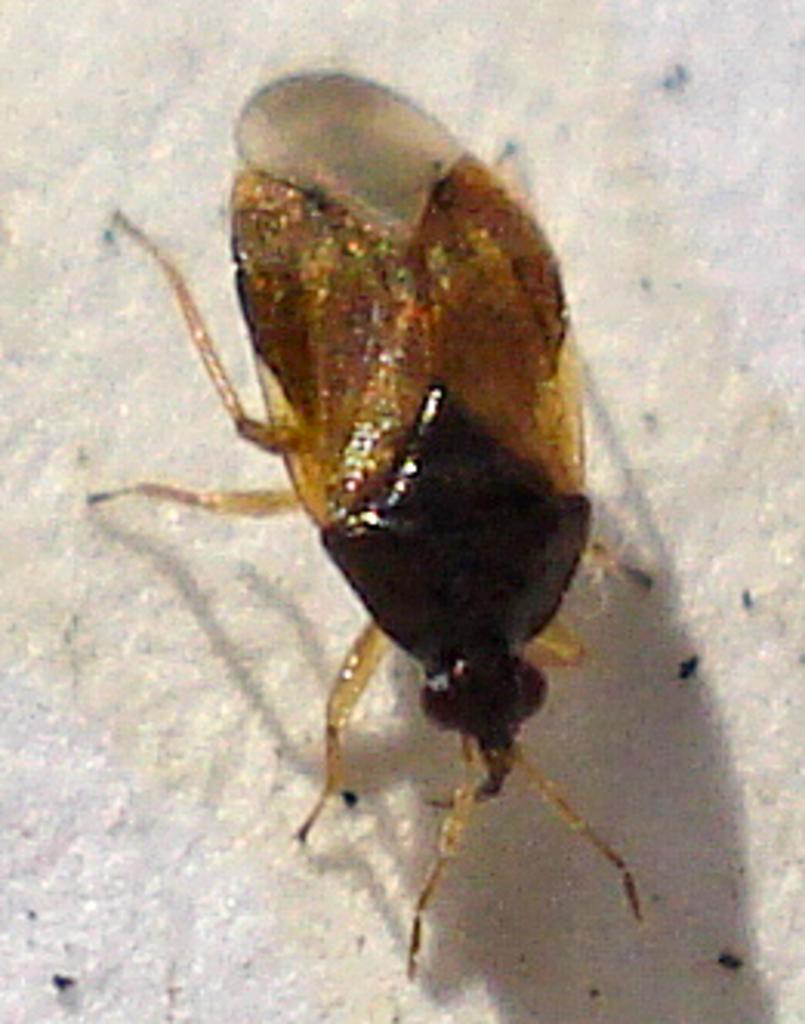What type of creature is present in the image? There is an insect in the image. What is the insect resting on in the image? The insect is on a white surface. What type of sweater is the insect wearing in the image? There is no sweater present in the image, as insects do not wear clothing. 